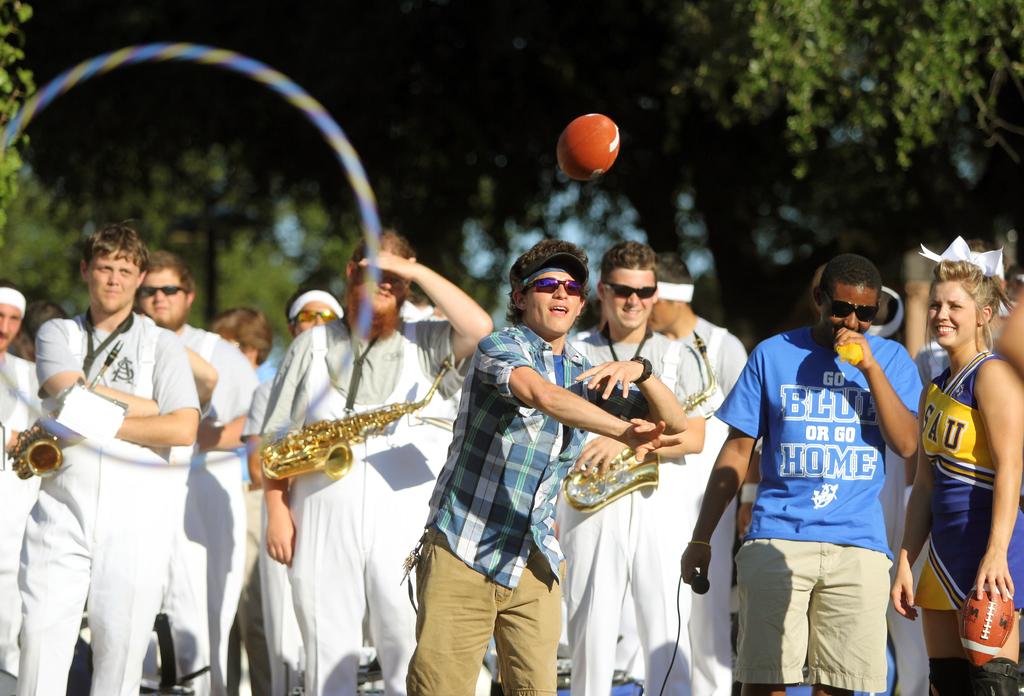What initials are on the saxophonists tshirt?
Your answer should be very brief. As. 